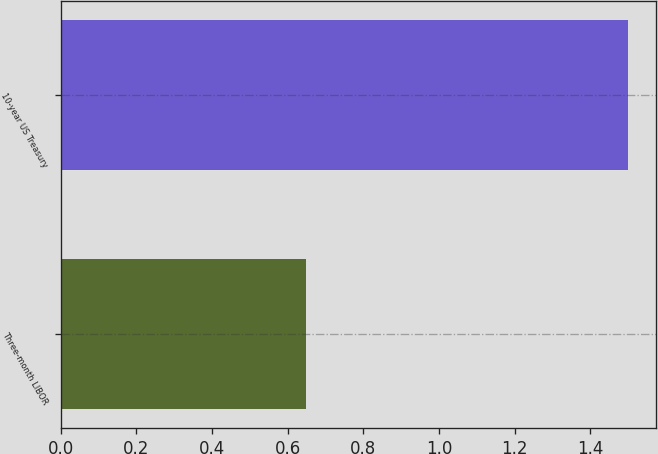Convert chart to OTSL. <chart><loc_0><loc_0><loc_500><loc_500><bar_chart><fcel>Three-month LIBOR<fcel>10-year US Treasury<nl><fcel>0.65<fcel>1.5<nl></chart> 